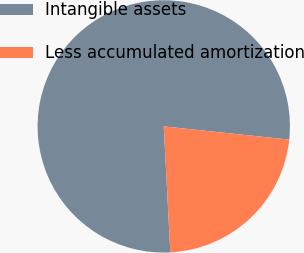Convert chart to OTSL. <chart><loc_0><loc_0><loc_500><loc_500><pie_chart><fcel>Intangible assets<fcel>Less accumulated amortization<nl><fcel>77.5%<fcel>22.5%<nl></chart> 